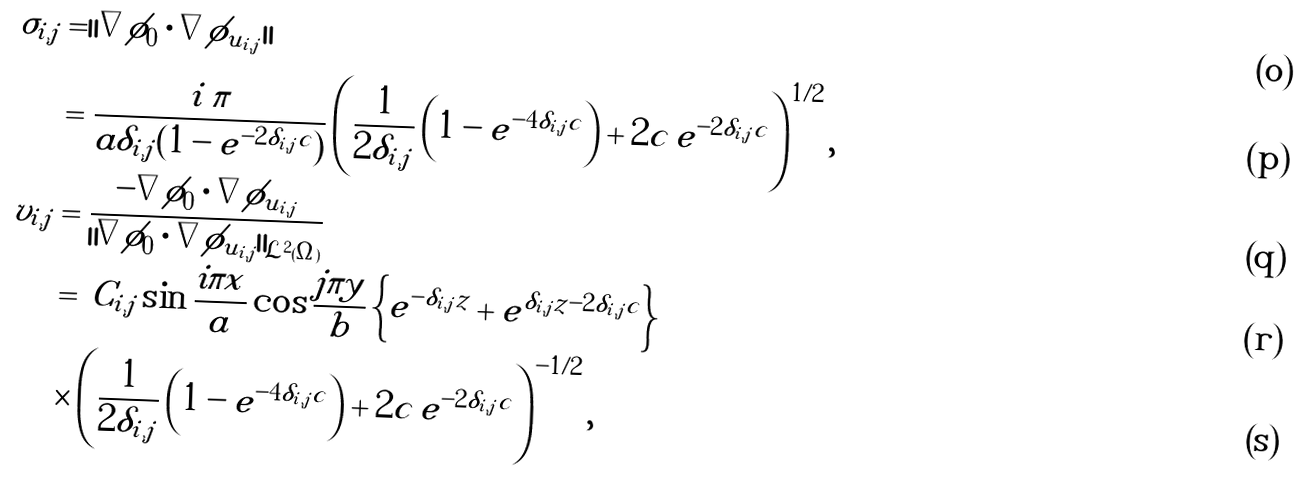Convert formula to latex. <formula><loc_0><loc_0><loc_500><loc_500>\sigma _ { i , j } & = | | \nabla \phi _ { 0 } \cdot \nabla \phi _ { \tilde { u } _ { i , j } } | | \\ & = \frac { i \, \pi } { a \delta _ { i , j } ( 1 - e ^ { - 2 \delta _ { i , j } c } ) } \left ( \frac { 1 } { 2 \delta _ { i , j } } \left ( 1 - e ^ { - 4 \delta _ { i , j } c } \right ) + 2 c \, e ^ { - 2 \delta _ { i , j } c } \right ) ^ { 1 / 2 } , \\ v _ { i , j } & = \frac { - \nabla \phi _ { 0 } \cdot \nabla \phi _ { \tilde { u } _ { i , j } } } { \| \nabla \phi _ { 0 } \cdot \nabla \phi _ { \tilde { u } _ { i , j } } \| _ { \mathcal { L } ^ { 2 } ( \Omega ) } } \\ & = \, C _ { i , j } \sin { \frac { i \pi x } { a } } \cos { \frac { j \pi y } { b } } \left \{ e ^ { - \delta _ { i , j } z } + e ^ { \delta _ { i , j } z - 2 \delta _ { i , j } c } \right \} \\ & \times \left ( \frac { 1 } { 2 \delta _ { i , j } } \left ( 1 - e ^ { - 4 \delta _ { i , j } c } \right ) + 2 c \, e ^ { - 2 \delta _ { i , j } c } \right ) ^ { - 1 / 2 } ,</formula> 